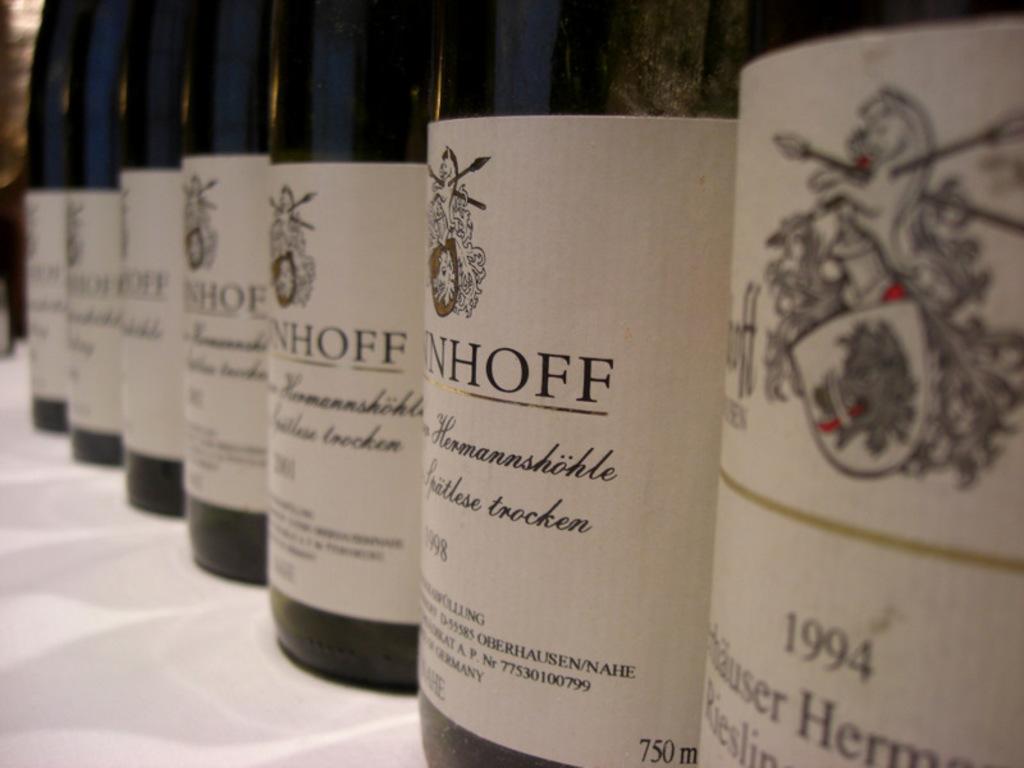What is the year of the bottle?
Your answer should be very brief. 1994. 